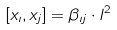<formula> <loc_0><loc_0><loc_500><loc_500>[ x _ { \imath } , x _ { j } ] = \beta _ { \imath j } \cdot l ^ { 2 }</formula> 